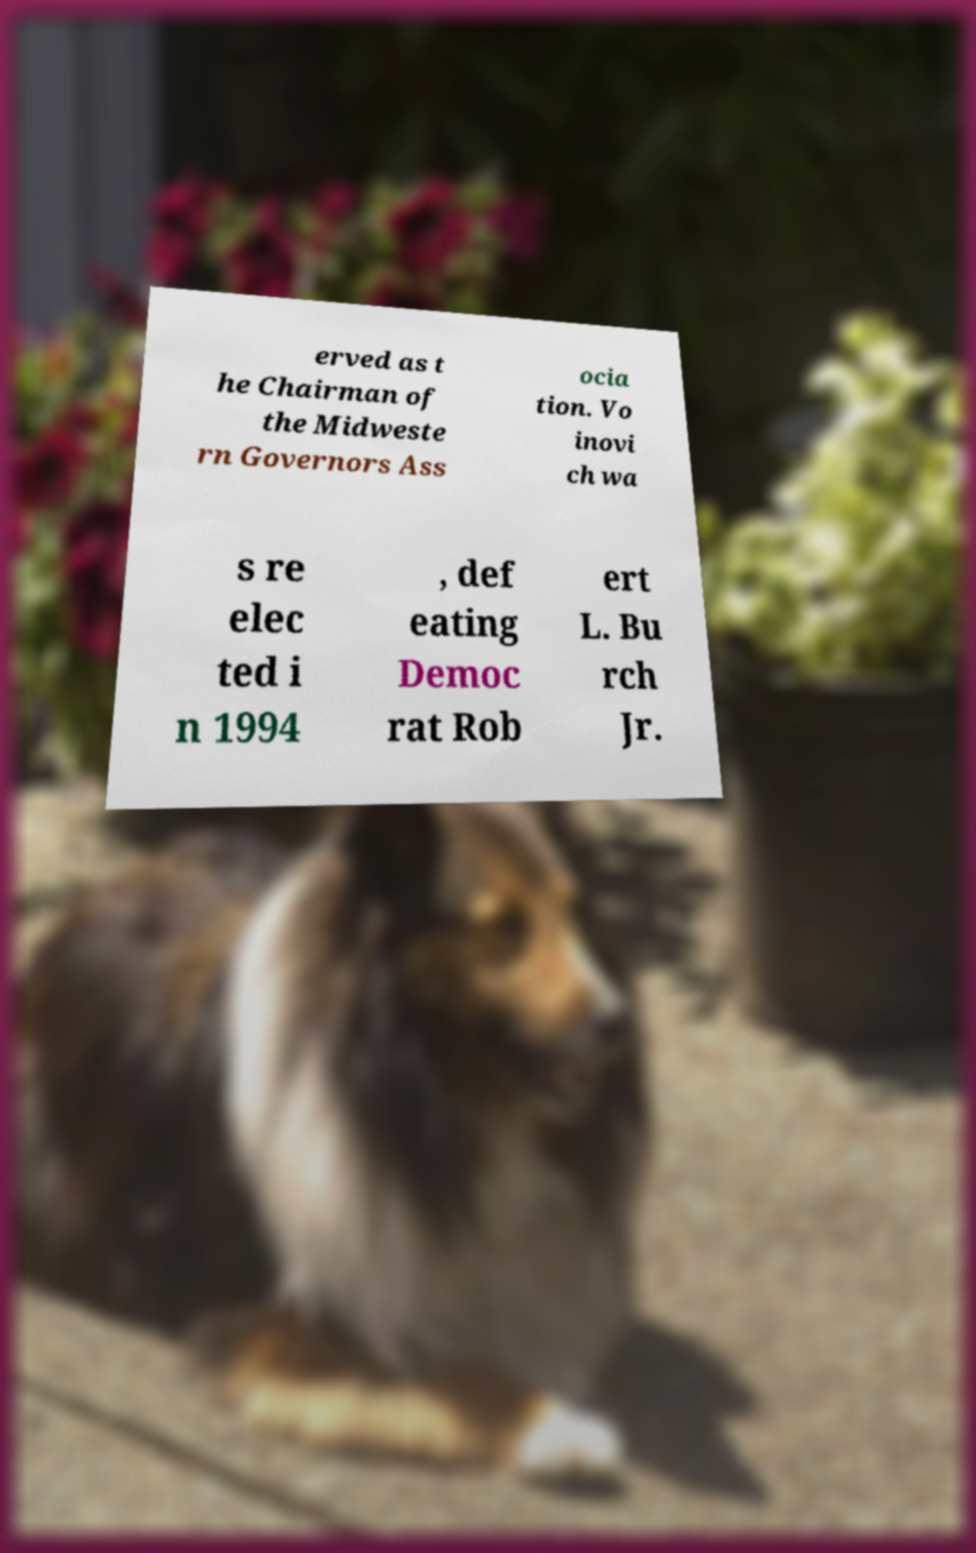Could you assist in decoding the text presented in this image and type it out clearly? erved as t he Chairman of the Midweste rn Governors Ass ocia tion. Vo inovi ch wa s re elec ted i n 1994 , def eating Democ rat Rob ert L. Bu rch Jr. 